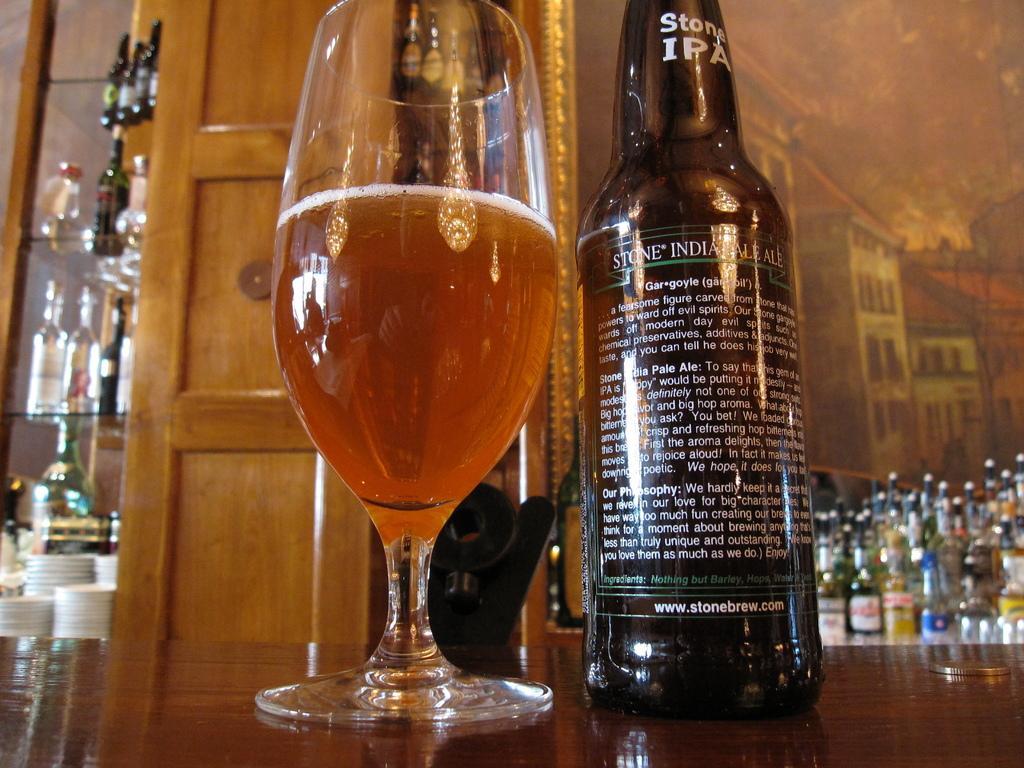In one or two sentences, can you explain what this image depicts? There is a bottle and a glass with some drink in it placed on the table side by side. In the background there are some bottles and a wall here along with the door. 